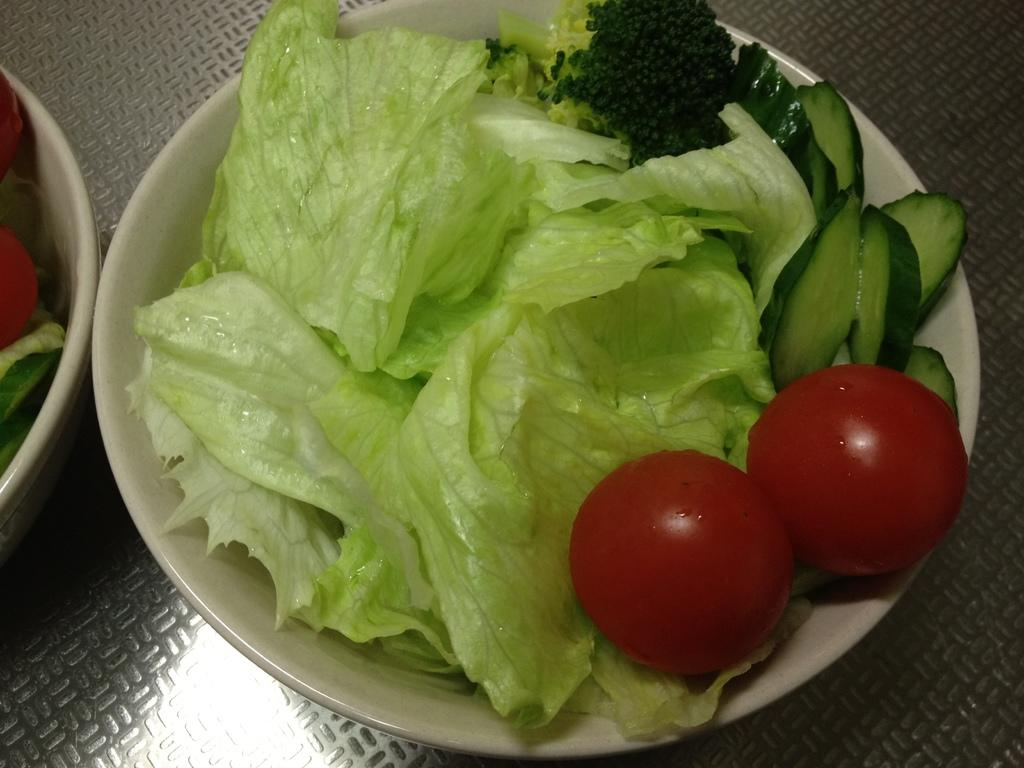What type of vegetables are in the bowl in the image? There is a bowl containing cabbage leaves, two red tomatoes, and cucumber pieces in the image. Are there any seeds visible in the bowl? Yes, there are black seeds in the bowl. Where is the bowl located in the image? The white bowl containing vegetables is on the left side of the image. What can be seen in the background of the image? There is a table visible in the background of the image. What type of representative is sitting at the table in the image? There is no representative present in the image; it features a bowl of vegetables and a table in the background. How many lizards can be seen crawling on the vegetables in the image? There are no lizards present in the image; it features a bowl of vegetables and a table in the background. 